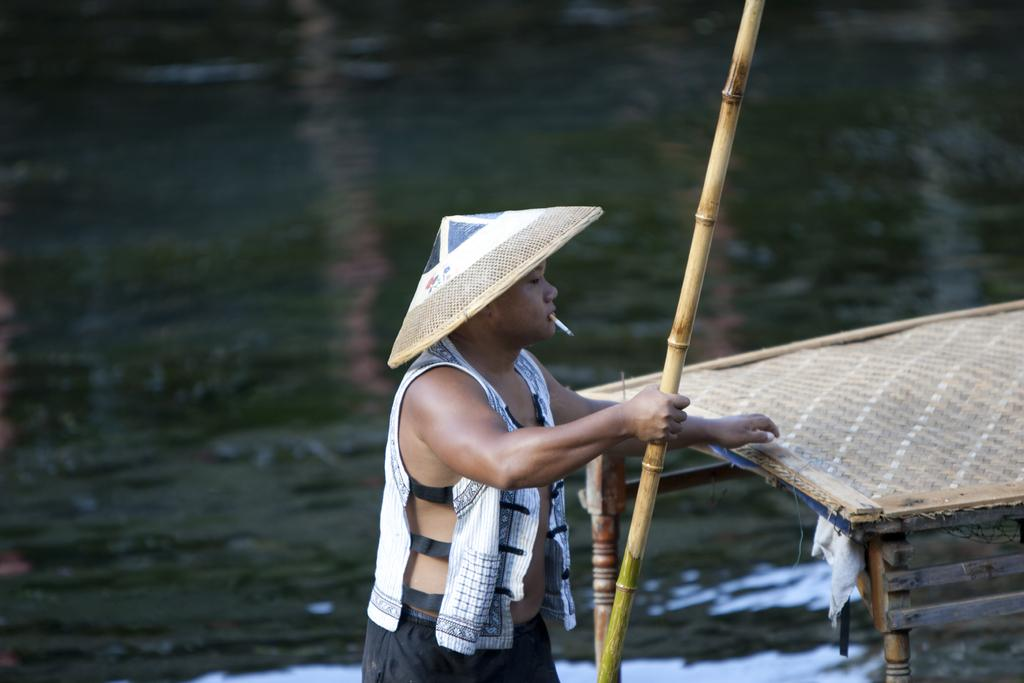What is the main subject of the image? There is a person in the image. What is the person holding in the image? The person is holding a stick. Can you describe the person's appearance or actions? The person has a cigarette in their mouth. What can be seen on the right side of the image? There is a wooden object on the right side of the image. What type of instrument is the person playing in the image? There is no instrument present in the image, and the person is not playing any instrument. How many babies are visible in the image? There are no babies present in the image. 